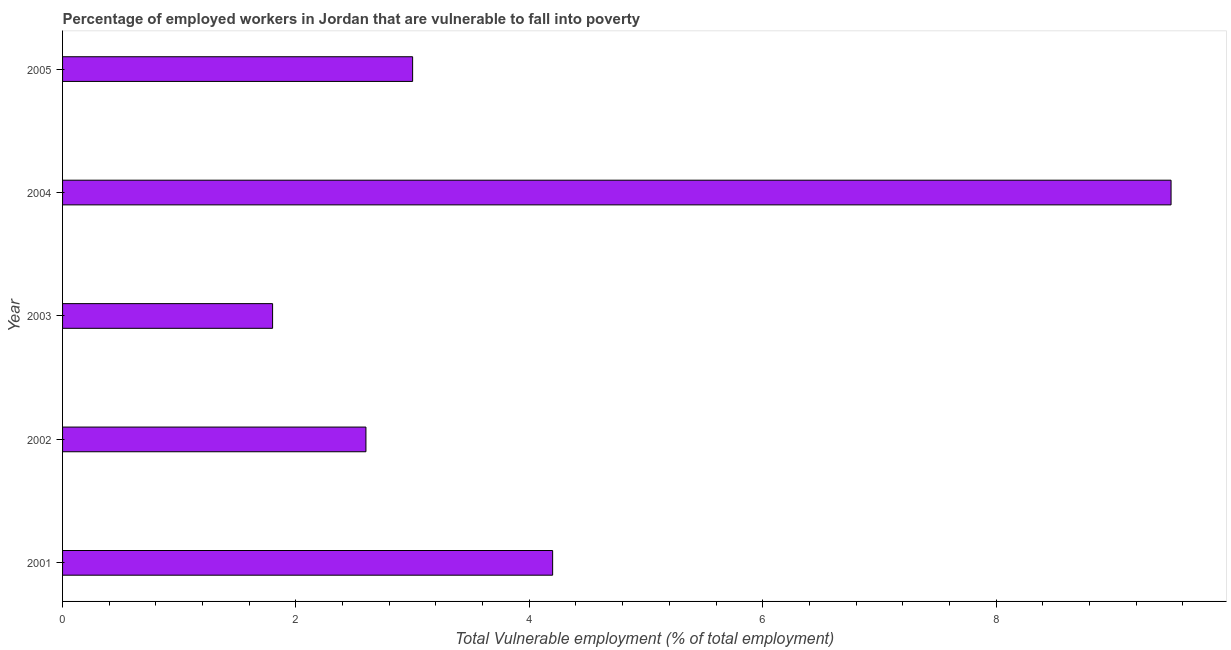Does the graph contain any zero values?
Offer a terse response. No. Does the graph contain grids?
Ensure brevity in your answer.  No. What is the title of the graph?
Ensure brevity in your answer.  Percentage of employed workers in Jordan that are vulnerable to fall into poverty. What is the label or title of the X-axis?
Keep it short and to the point. Total Vulnerable employment (% of total employment). What is the total vulnerable employment in 2005?
Offer a terse response. 3. Across all years, what is the minimum total vulnerable employment?
Ensure brevity in your answer.  1.8. What is the sum of the total vulnerable employment?
Your answer should be compact. 21.1. What is the difference between the total vulnerable employment in 2001 and 2002?
Your response must be concise. 1.6. What is the average total vulnerable employment per year?
Your answer should be very brief. 4.22. What is the median total vulnerable employment?
Ensure brevity in your answer.  3. Do a majority of the years between 2002 and 2001 (inclusive) have total vulnerable employment greater than 2 %?
Make the answer very short. No. What is the ratio of the total vulnerable employment in 2002 to that in 2004?
Your response must be concise. 0.27. Is the total vulnerable employment in 2001 less than that in 2004?
Make the answer very short. Yes. Is the difference between the total vulnerable employment in 2002 and 2005 greater than the difference between any two years?
Keep it short and to the point. No. What is the difference between the highest and the second highest total vulnerable employment?
Offer a very short reply. 5.3. Is the sum of the total vulnerable employment in 2003 and 2004 greater than the maximum total vulnerable employment across all years?
Make the answer very short. Yes. How many bars are there?
Ensure brevity in your answer.  5. What is the Total Vulnerable employment (% of total employment) of 2001?
Offer a terse response. 4.2. What is the Total Vulnerable employment (% of total employment) of 2002?
Your answer should be very brief. 2.6. What is the Total Vulnerable employment (% of total employment) of 2003?
Give a very brief answer. 1.8. What is the Total Vulnerable employment (% of total employment) of 2004?
Ensure brevity in your answer.  9.5. What is the difference between the Total Vulnerable employment (% of total employment) in 2001 and 2002?
Offer a terse response. 1.6. What is the difference between the Total Vulnerable employment (% of total employment) in 2001 and 2003?
Provide a short and direct response. 2.4. What is the difference between the Total Vulnerable employment (% of total employment) in 2002 and 2003?
Offer a terse response. 0.8. What is the difference between the Total Vulnerable employment (% of total employment) in 2002 and 2004?
Offer a very short reply. -6.9. What is the difference between the Total Vulnerable employment (% of total employment) in 2003 and 2004?
Your answer should be compact. -7.7. What is the ratio of the Total Vulnerable employment (% of total employment) in 2001 to that in 2002?
Provide a short and direct response. 1.61. What is the ratio of the Total Vulnerable employment (% of total employment) in 2001 to that in 2003?
Provide a succinct answer. 2.33. What is the ratio of the Total Vulnerable employment (% of total employment) in 2001 to that in 2004?
Your answer should be very brief. 0.44. What is the ratio of the Total Vulnerable employment (% of total employment) in 2001 to that in 2005?
Provide a short and direct response. 1.4. What is the ratio of the Total Vulnerable employment (% of total employment) in 2002 to that in 2003?
Your answer should be compact. 1.44. What is the ratio of the Total Vulnerable employment (% of total employment) in 2002 to that in 2004?
Provide a short and direct response. 0.27. What is the ratio of the Total Vulnerable employment (% of total employment) in 2002 to that in 2005?
Offer a very short reply. 0.87. What is the ratio of the Total Vulnerable employment (% of total employment) in 2003 to that in 2004?
Make the answer very short. 0.19. What is the ratio of the Total Vulnerable employment (% of total employment) in 2004 to that in 2005?
Provide a short and direct response. 3.17. 